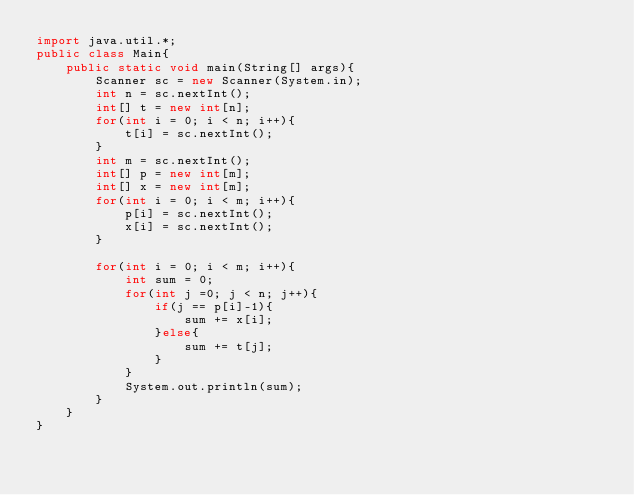Convert code to text. <code><loc_0><loc_0><loc_500><loc_500><_Java_>import java.util.*;
public class Main{
	public static void main(String[] args){
    	Scanner sc = new Scanner(System.in);
      	int n = sc.nextInt();
      	int[] t = new int[n];
      	for(int i = 0; i < n; i++){
        	t[i] = sc.nextInt();
        }
      	int m = sc.nextInt();
      	int[] p = new int[m];
      	int[] x = new int[m];
      	for(int i = 0; i < m; i++){
        	p[i] = sc.nextInt();
          	x[i] = sc.nextInt();
        }
      
      	for(int i = 0; i < m; i++){
        	int sum = 0;
          	for(int j =0; j < n; j++){
            	if(j == p[i]-1){
                	sum += x[i];
                }else{
              		sum += t[j];
                }
            }
          	System.out.println(sum);
        }
    }
}</code> 